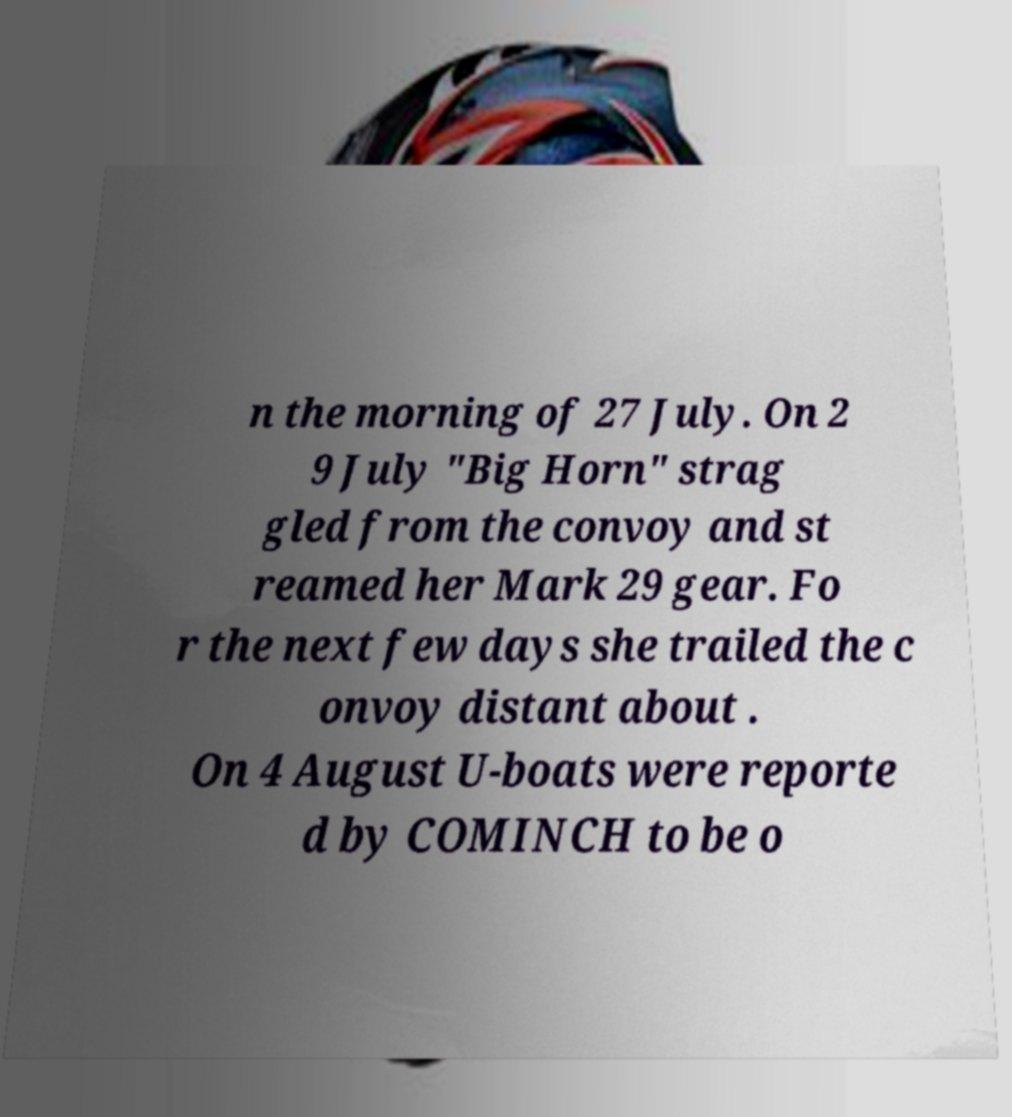For documentation purposes, I need the text within this image transcribed. Could you provide that? n the morning of 27 July. On 2 9 July "Big Horn" strag gled from the convoy and st reamed her Mark 29 gear. Fo r the next few days she trailed the c onvoy distant about . On 4 August U-boats were reporte d by COMINCH to be o 